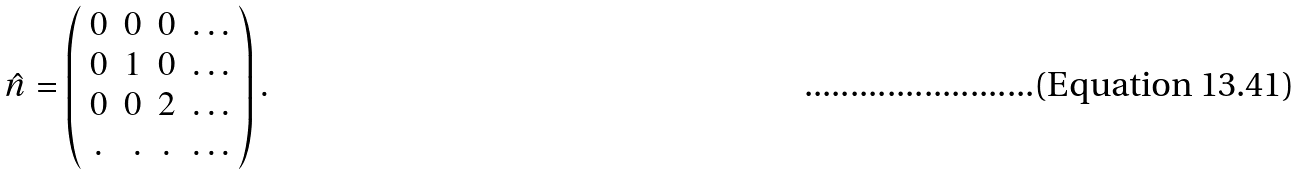<formula> <loc_0><loc_0><loc_500><loc_500>\hat { n } = \left ( \begin{array} { c r c l } 0 & 0 & 0 & \dots \\ 0 & 1 & 0 & \dots \\ 0 & 0 & 2 & \dots \\ . & . & . & \dots \\ \end{array} \right ) .</formula> 